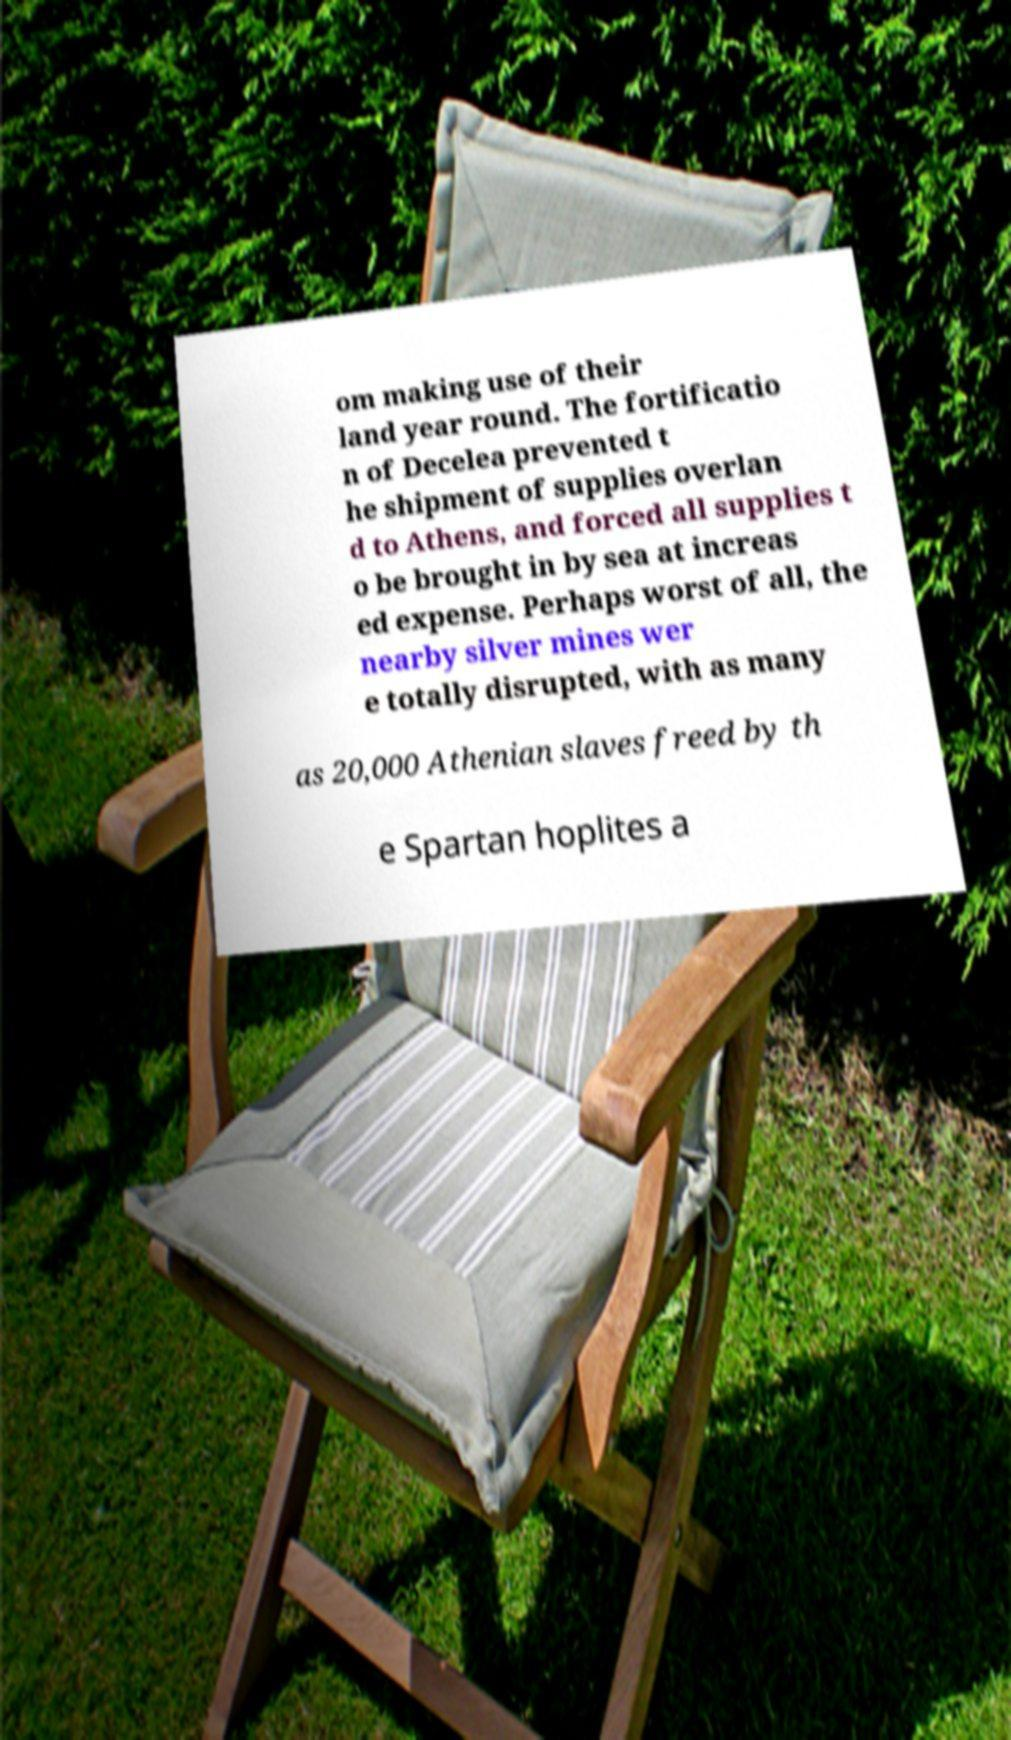Please read and relay the text visible in this image. What does it say? om making use of their land year round. The fortificatio n of Decelea prevented t he shipment of supplies overlan d to Athens, and forced all supplies t o be brought in by sea at increas ed expense. Perhaps worst of all, the nearby silver mines wer e totally disrupted, with as many as 20,000 Athenian slaves freed by th e Spartan hoplites a 